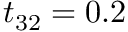Convert formula to latex. <formula><loc_0><loc_0><loc_500><loc_500>t _ { 3 2 } = 0 . 2</formula> 